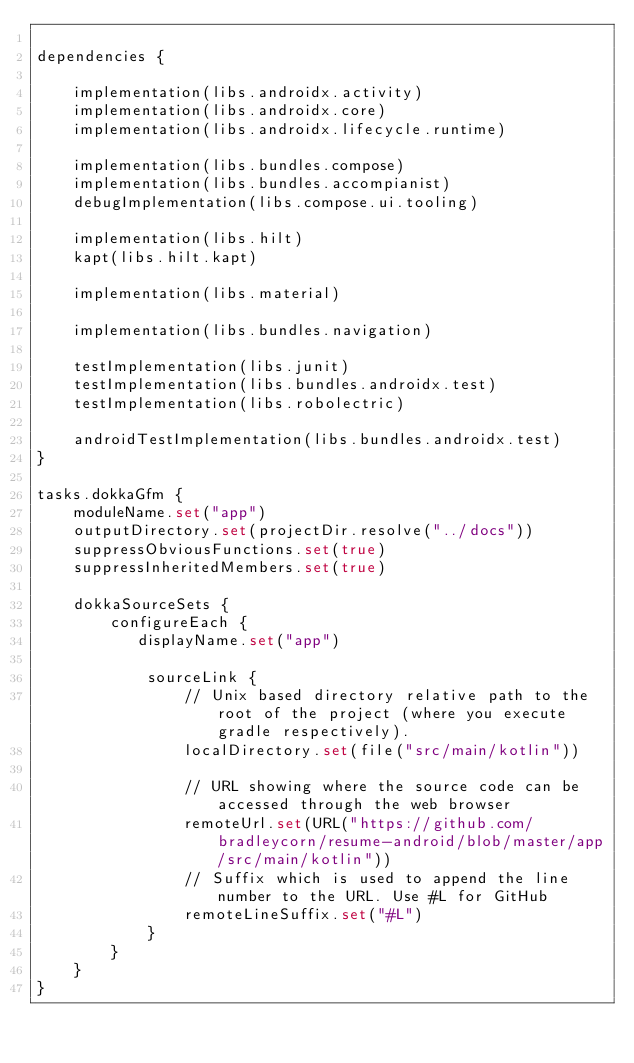<code> <loc_0><loc_0><loc_500><loc_500><_Kotlin_>
dependencies {

    implementation(libs.androidx.activity)
    implementation(libs.androidx.core)
    implementation(libs.androidx.lifecycle.runtime)

    implementation(libs.bundles.compose)
    implementation(libs.bundles.accompianist)
    debugImplementation(libs.compose.ui.tooling)

    implementation(libs.hilt)
    kapt(libs.hilt.kapt)

    implementation(libs.material)

    implementation(libs.bundles.navigation)

    testImplementation(libs.junit)
    testImplementation(libs.bundles.androidx.test)
    testImplementation(libs.robolectric)

    androidTestImplementation(libs.bundles.androidx.test)
}

tasks.dokkaGfm {
    moduleName.set("app")
    outputDirectory.set(projectDir.resolve("../docs"))
    suppressObviousFunctions.set(true)
    suppressInheritedMembers.set(true)

    dokkaSourceSets {
        configureEach {
           displayName.set("app")

            sourceLink {
                // Unix based directory relative path to the root of the project (where you execute gradle respectively).
                localDirectory.set(file("src/main/kotlin"))

                // URL showing where the source code can be accessed through the web browser
                remoteUrl.set(URL("https://github.com/bradleycorn/resume-android/blob/master/app/src/main/kotlin"))
                // Suffix which is used to append the line number to the URL. Use #L for GitHub
                remoteLineSuffix.set("#L")
            }
        }
    }
}</code> 